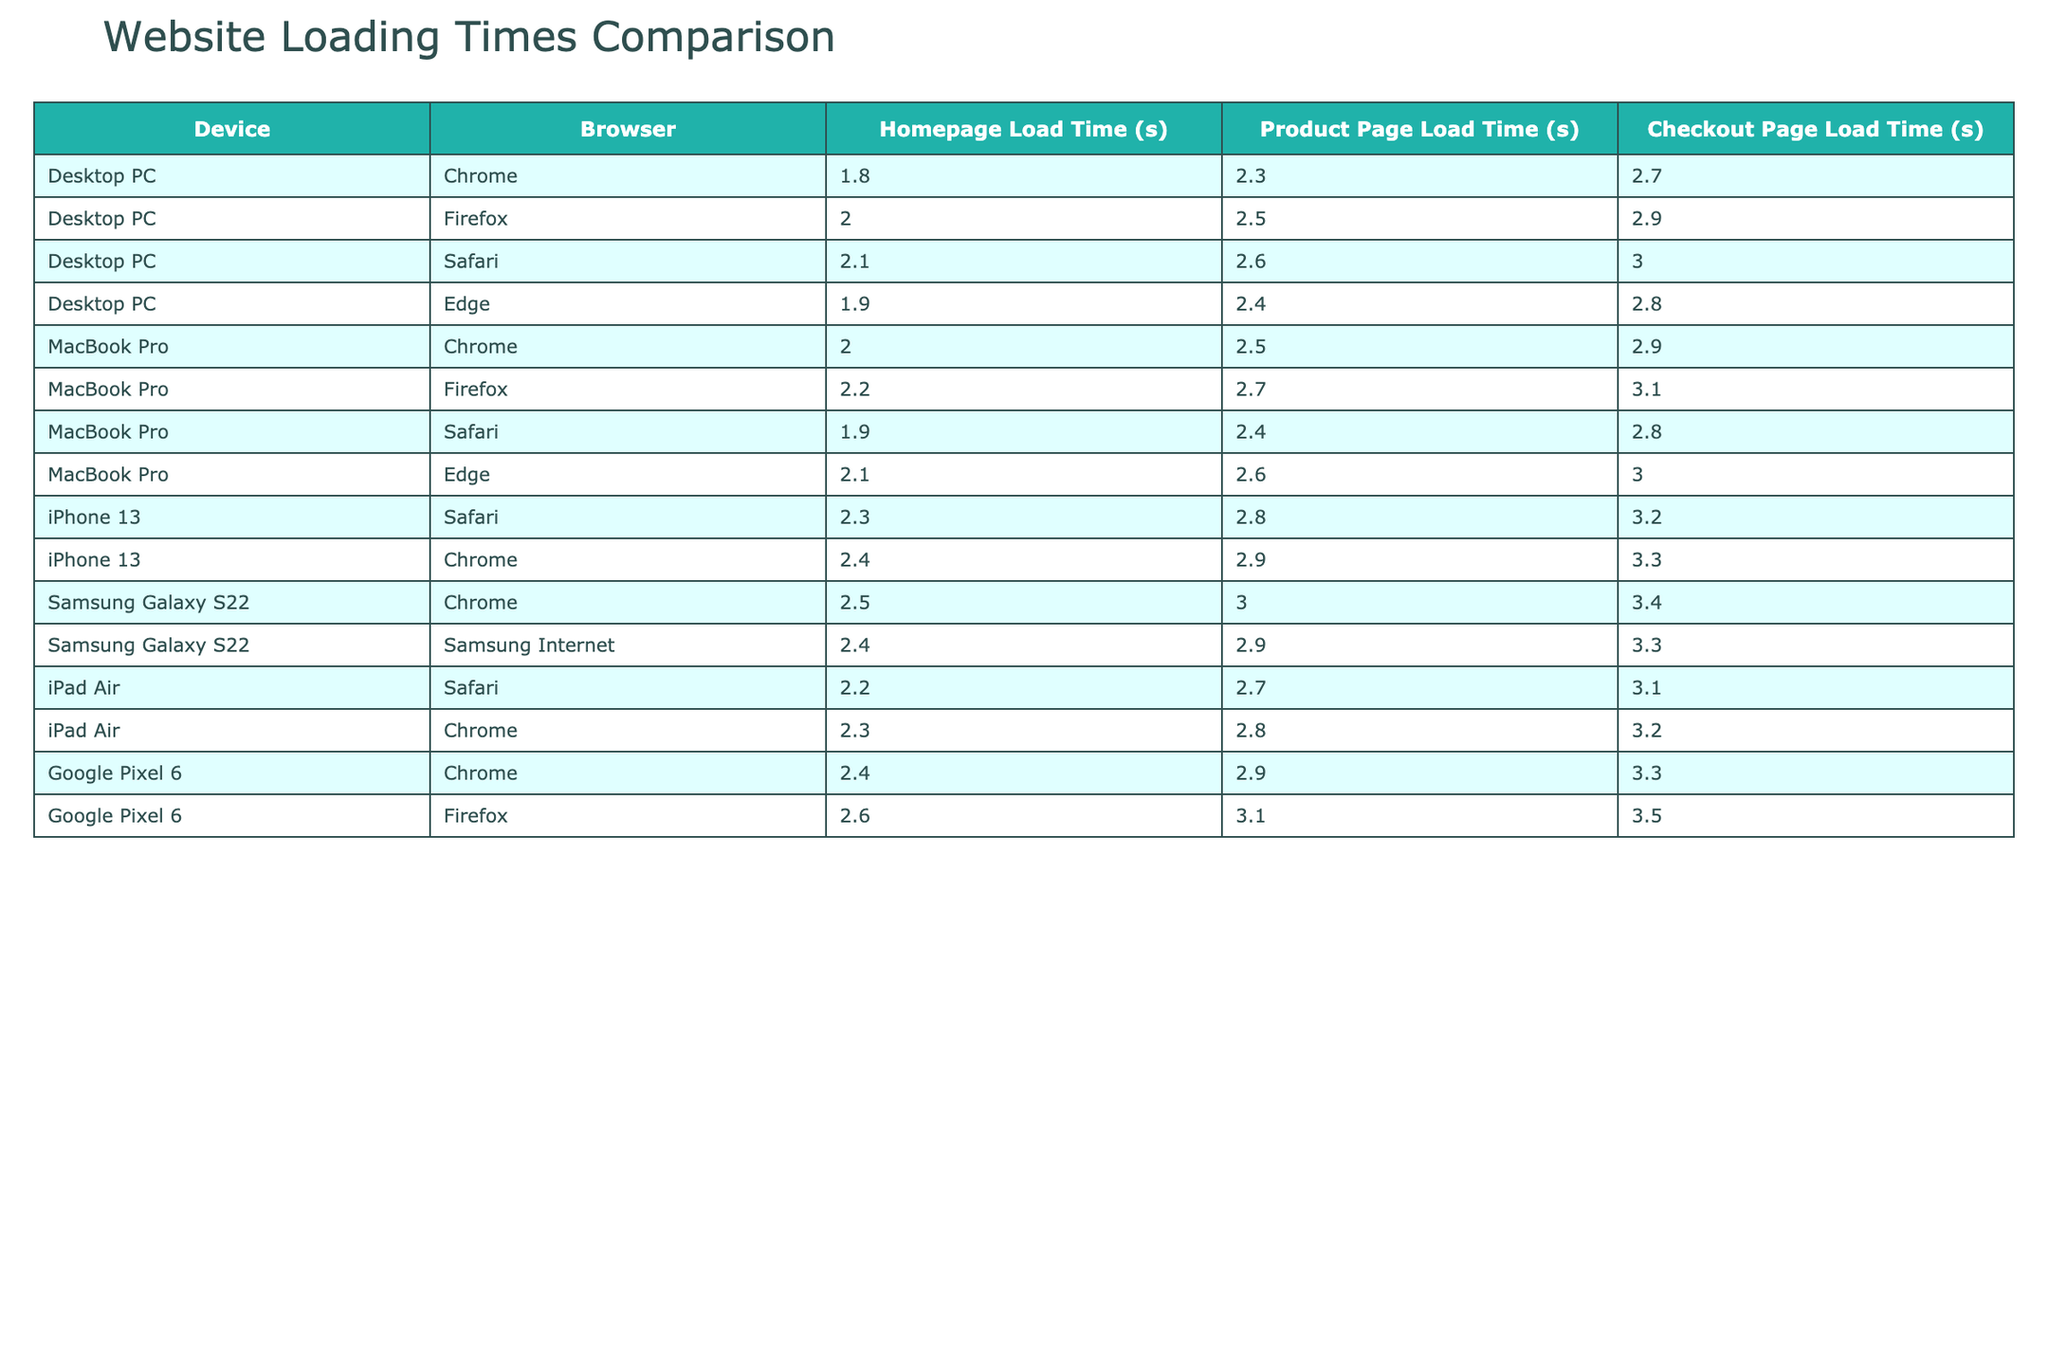What is the homepage load time for the iPhone 13 using Safari? The table shows that for the iPhone 13 using Safari, the homepage load time is 2.3 seconds.
Answer: 2.3 seconds Which browser has the fastest product page load time on a Desktop PC? On the Desktop PC, the Chrome browser has the fastest product page load time of 2.3 seconds, while the other browsers take longer.
Answer: Chrome What is the average checkout page load time for all devices using Chrome? To find the average checkout page load time for Chrome, we look at the checkout times: Desktop PC (2.7), MacBook Pro (2.9), iPhone 13 (3.3), Samsung Galaxy S22 (3.4), iPad Air (3.2), and Google Pixel 6 (3.3). Summing these values gives us (2.7 + 2.9 + 3.3 + 3.4 + 3.2 + 3.3) = 19.8 seconds. Dividing by the number of data points (6), the average checkout time is 19.8/6 = 3.3 seconds.
Answer: 3.3 seconds Is the product page load time for MacBook Pro using Safari lower than that of Samsung Galaxy S22 using Chrome? The product page load time for MacBook Pro using Safari is 2.4 seconds, while for Samsung Galaxy S22 using Chrome it is 3.0 seconds. Since 2.4 is less than 3.0, the statement is true.
Answer: Yes What is the difference in homepage load time between the fastest and slowest browser on a Desktop PC? The fastest homepage load time on a Desktop PC is recorded with Chrome at 1.8 seconds, while the slowest is with Safari at 2.1 seconds. The difference is 2.1 - 1.8 = 0.3 seconds, showing that Chrome is faster by this amount.
Answer: 0.3 seconds 